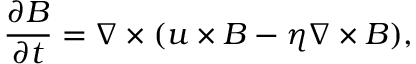Convert formula to latex. <formula><loc_0><loc_0><loc_500><loc_500>\frac { \partial B } { \partial t } = \nabla \times ( u \times B - \eta \nabla \times B ) ,</formula> 